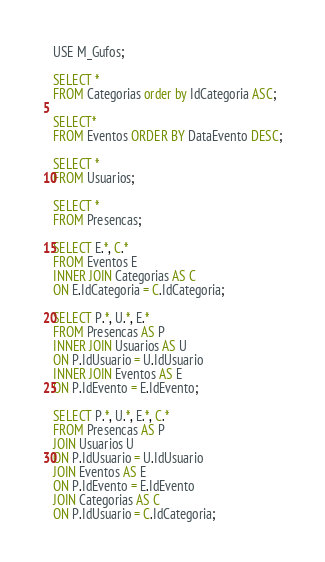<code> <loc_0><loc_0><loc_500><loc_500><_SQL_>USE M_Gufos;

SELECT *
FROM Categorias order by IdCategoria ASC;

SELECT*
FROM Eventos ORDER BY DataEvento DESC;

SELECT *
FROM Usuarios;

SELECT * 
FROM Presencas;

SELECT E.*, C.* 
FROM Eventos E
INNER JOIN Categorias AS C
ON E.IdCategoria = C.IdCategoria;

SELECT P.*, U.*, E.*
FROM Presencas AS P
INNER JOIN Usuarios AS U 
ON P.IdUsuario = U.IdUsuario
INNER JOIN Eventos AS E
ON P.IdEvento = E.IdEvento;

SELECT P.*, U.*, E.*, C.*
FROM Presencas AS P
JOIN Usuarios U
ON P.IdUsuario = U.IdUsuario
JOIN Eventos AS E
ON P.IdEvento = E.IdEvento
JOIN Categorias AS C
ON P.IdUsuario = C.IdCategoria; 
</code> 